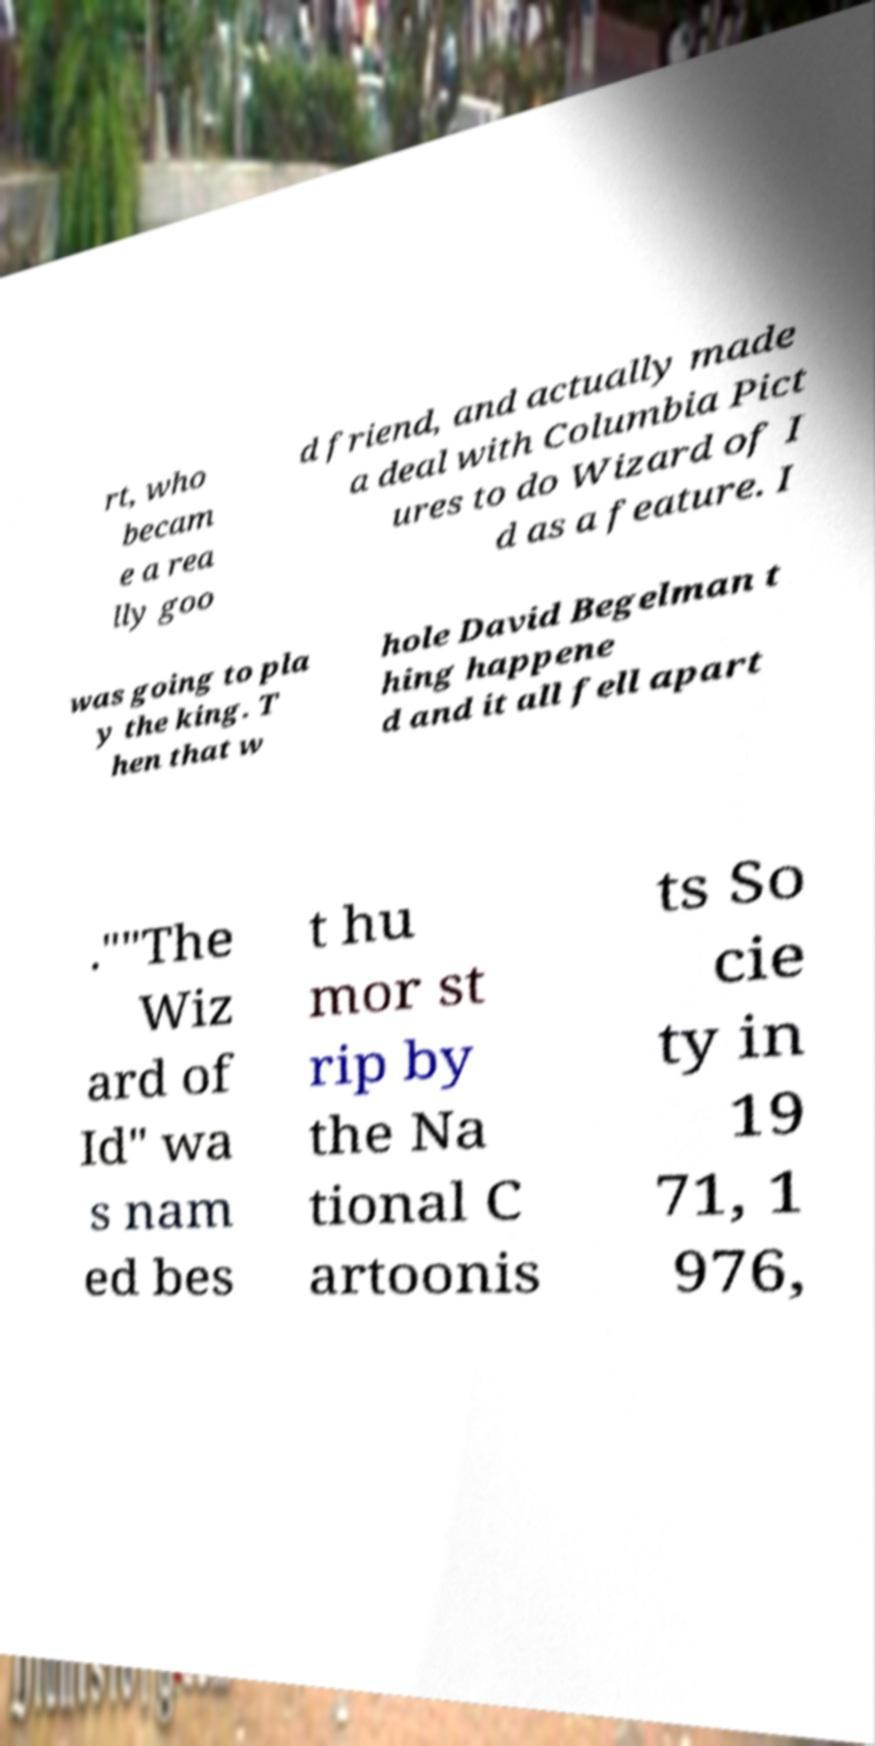There's text embedded in this image that I need extracted. Can you transcribe it verbatim? rt, who becam e a rea lly goo d friend, and actually made a deal with Columbia Pict ures to do Wizard of I d as a feature. I was going to pla y the king. T hen that w hole David Begelman t hing happene d and it all fell apart .""The Wiz ard of Id" wa s nam ed bes t hu mor st rip by the Na tional C artoonis ts So cie ty in 19 71, 1 976, 